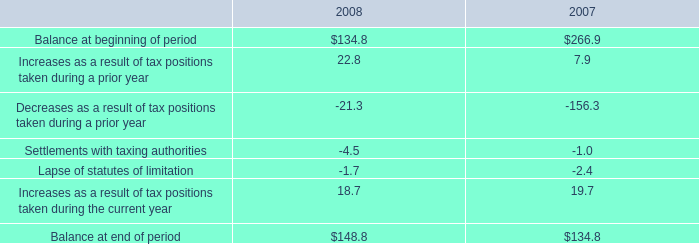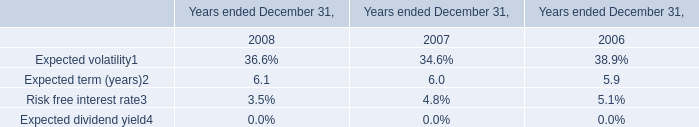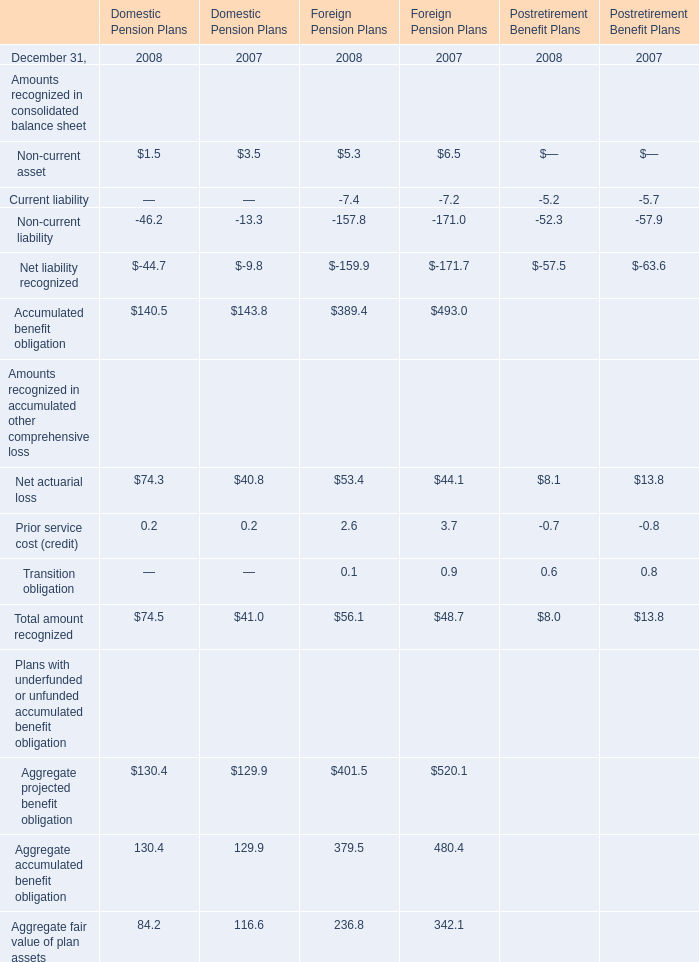Which year is Total amount recognized in accumulated other comprehensive loss for Postretirement Benefit Plans the least? 
Answer: 2008. 